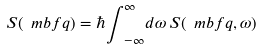Convert formula to latex. <formula><loc_0><loc_0><loc_500><loc_500>S ( \ m b f { q } ) = \hbar { \int } _ { - \infty } ^ { \infty } d \omega \, S ( \ m b f { q } , \omega )</formula> 